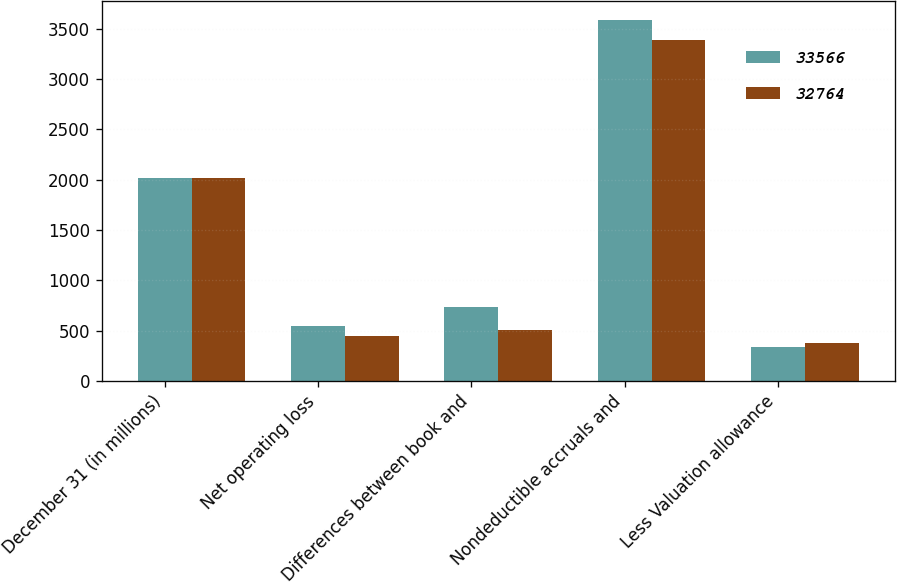Convert chart to OTSL. <chart><loc_0><loc_0><loc_500><loc_500><stacked_bar_chart><ecel><fcel>December 31 (in millions)<fcel>Net operating loss<fcel>Differences between book and<fcel>Nondeductible accruals and<fcel>Less Valuation allowance<nl><fcel>33566<fcel>2015<fcel>551<fcel>731<fcel>3589<fcel>342<nl><fcel>32764<fcel>2014<fcel>448<fcel>504<fcel>3383<fcel>375<nl></chart> 